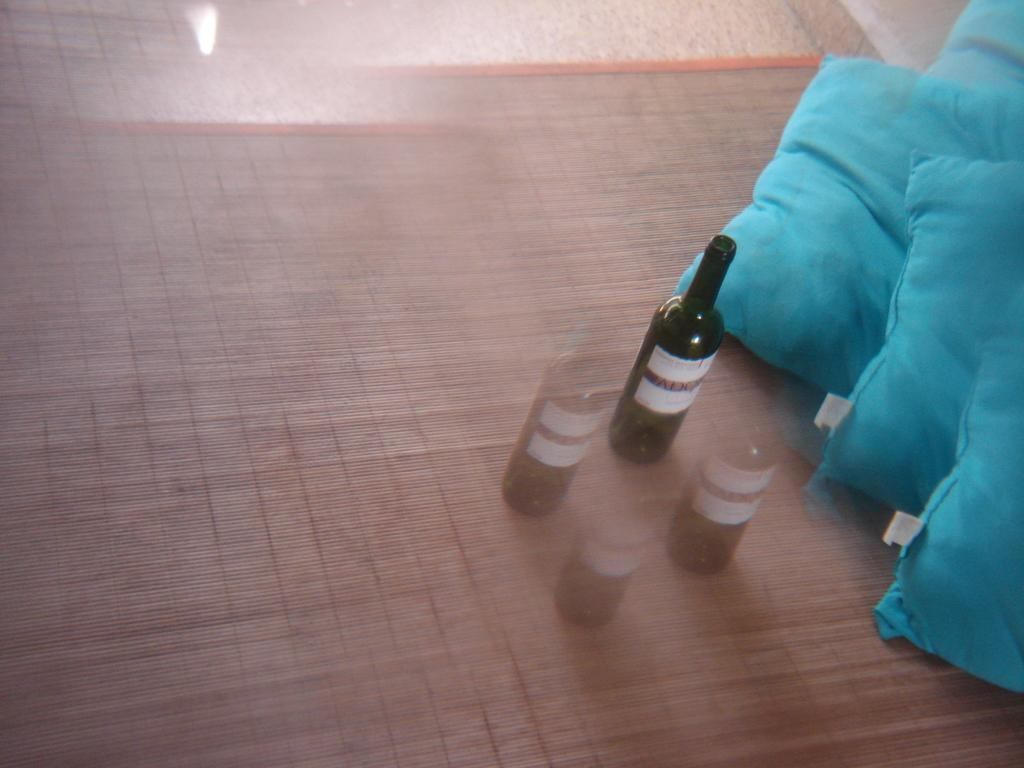What objects are on the mat in the image? There are bottles and pillows on the mat in the image. Where is the mat located? The mat is on the floor. What shape is the body of the person lying on the mat in the image? There is no person lying on the mat in the image, so we cannot determine the shape of their body. 